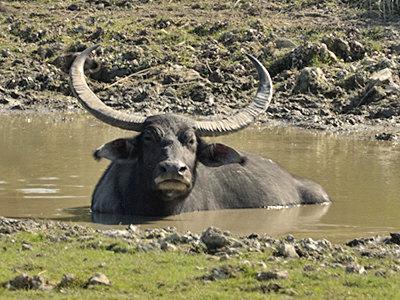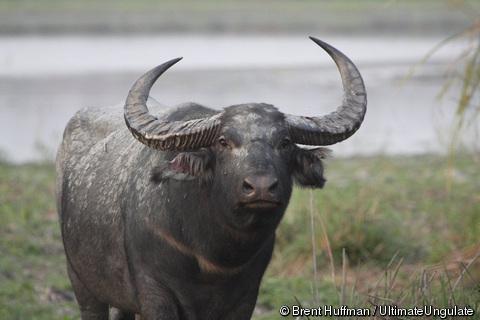The first image is the image on the left, the second image is the image on the right. For the images shown, is this caption "The left image shows exactly one horned animal standing in a grassy area." true? Answer yes or no. No. 